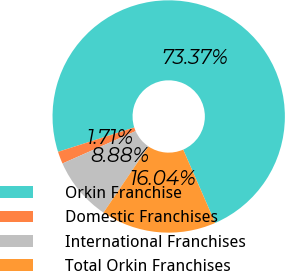<chart> <loc_0><loc_0><loc_500><loc_500><pie_chart><fcel>Orkin Franchise<fcel>Domestic Franchises<fcel>International Franchises<fcel>Total Orkin Franchises<nl><fcel>73.37%<fcel>1.71%<fcel>8.88%<fcel>16.04%<nl></chart> 